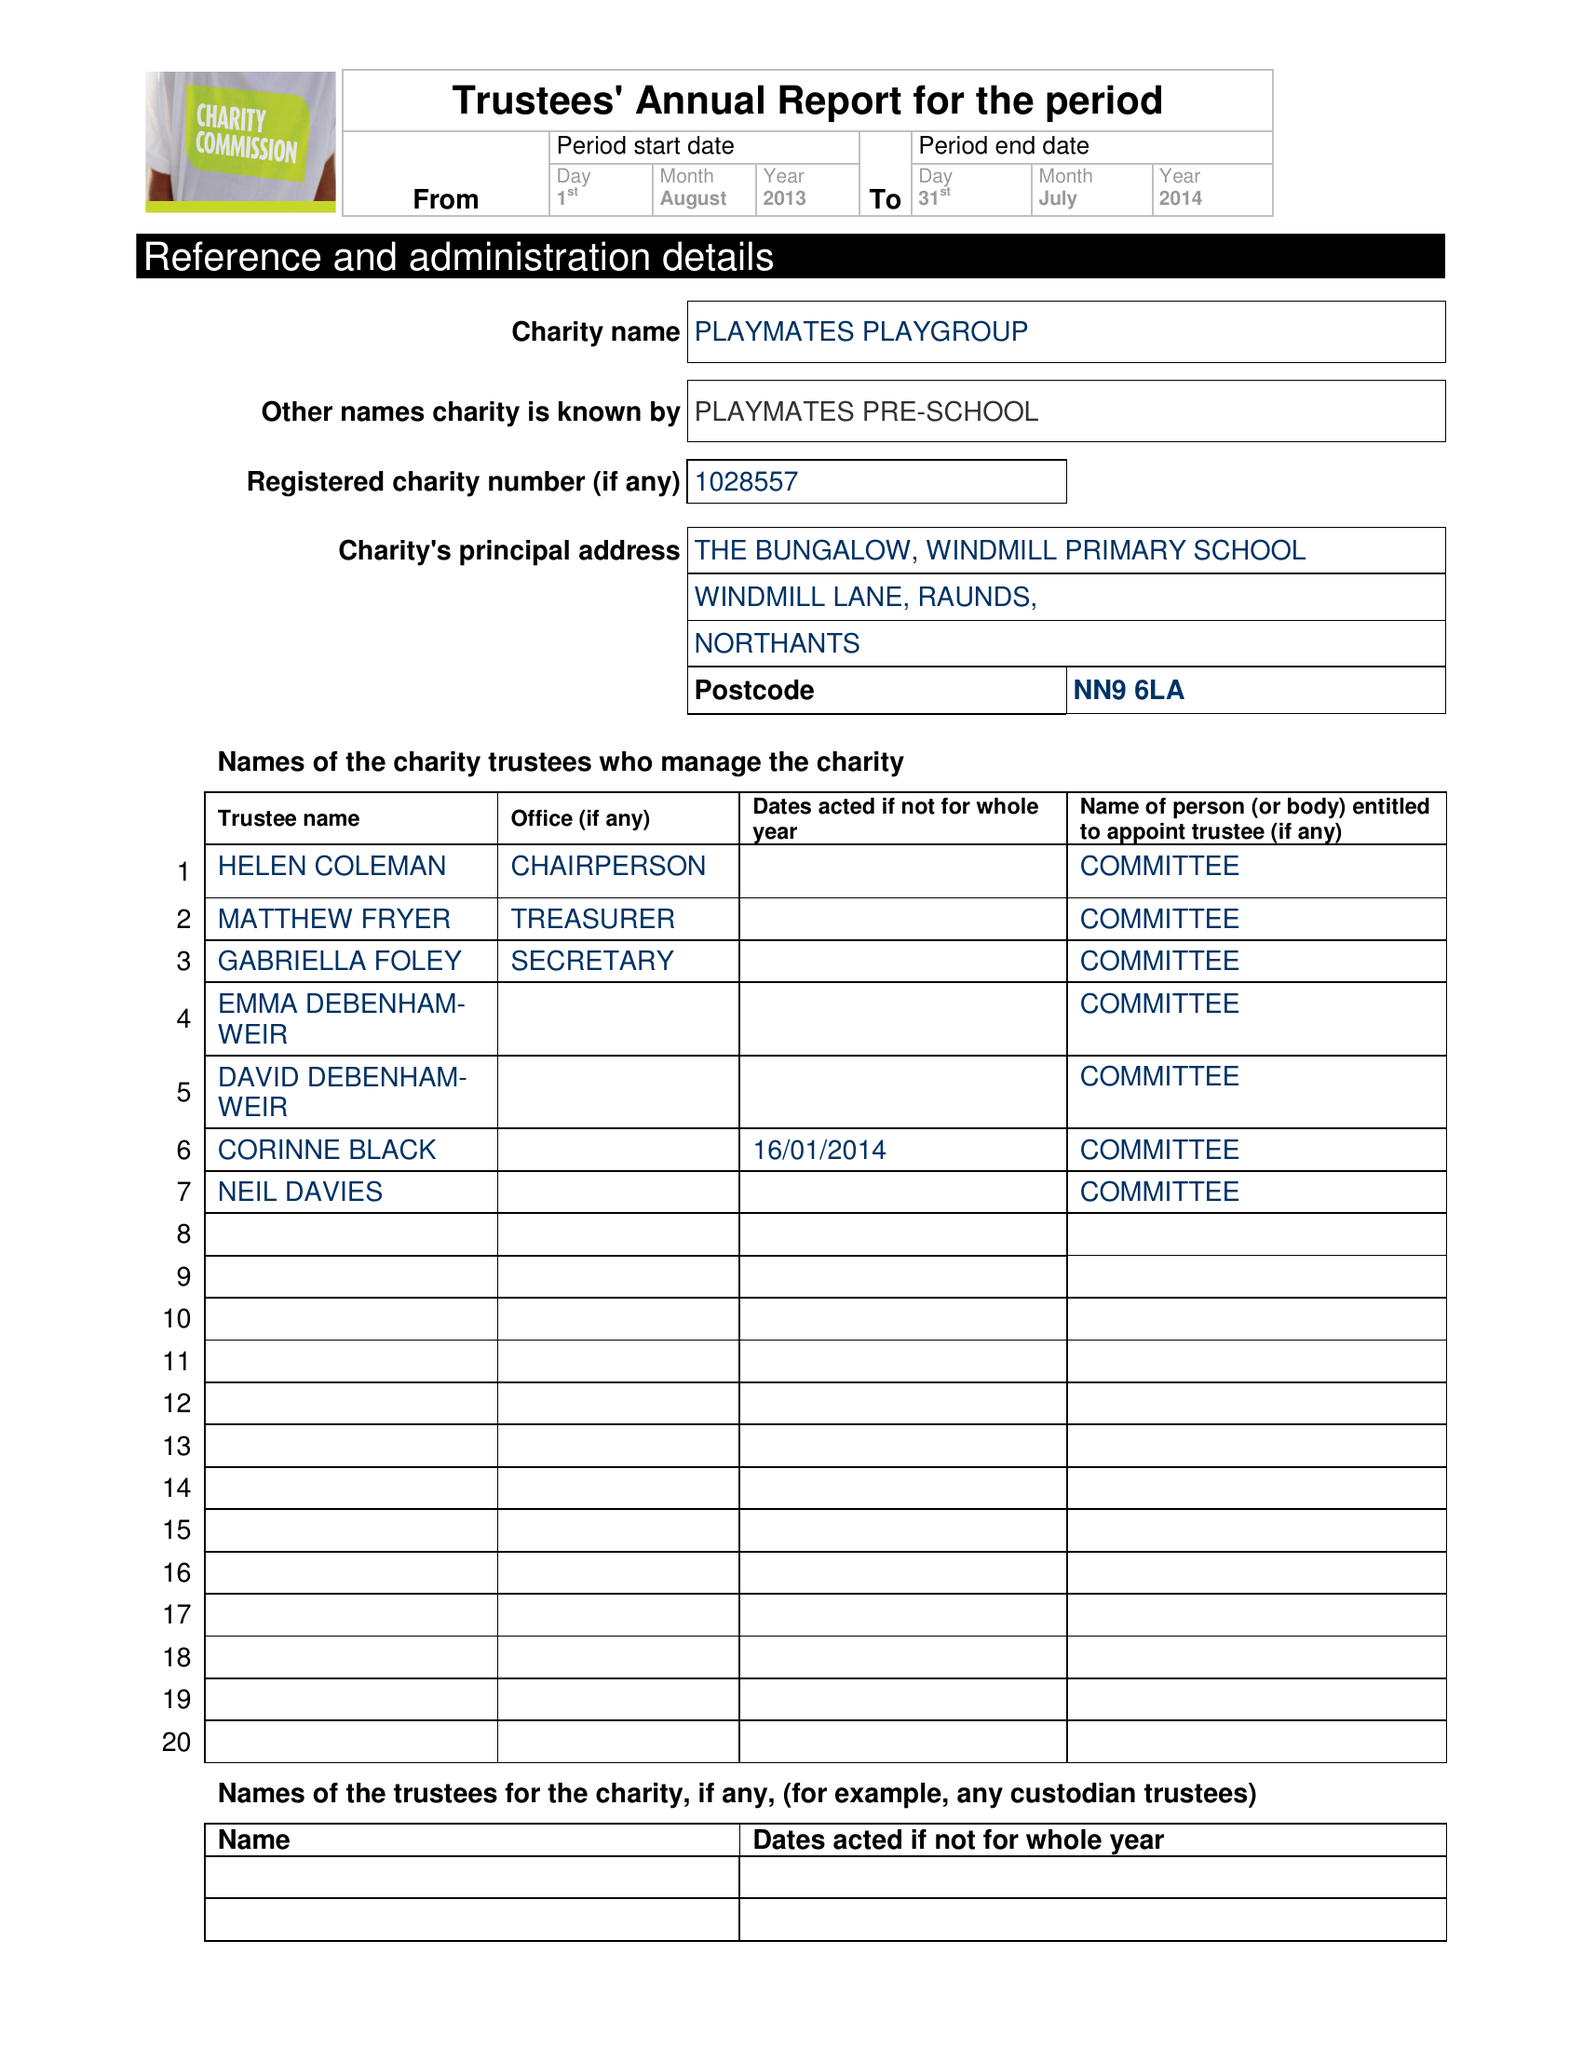What is the value for the address__street_line?
Answer the question using a single word or phrase. WINDMILL LANE 